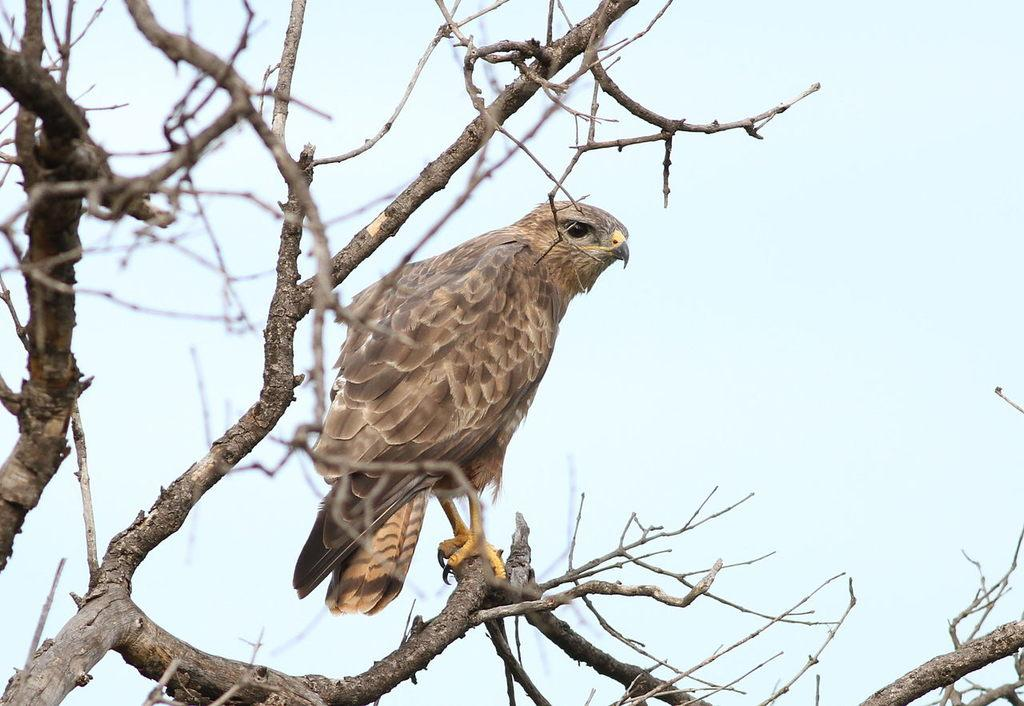What type of animal can be seen in the image? There is a bird in the image. Where is the bird located in the image? The bird is on the branch of a tree. What can be seen in the background of the image? The sky is visible in the background of the image. What type of whip is the bird using to fly in the image? There is no whip present in the image, and birds do not use whips to fly. 